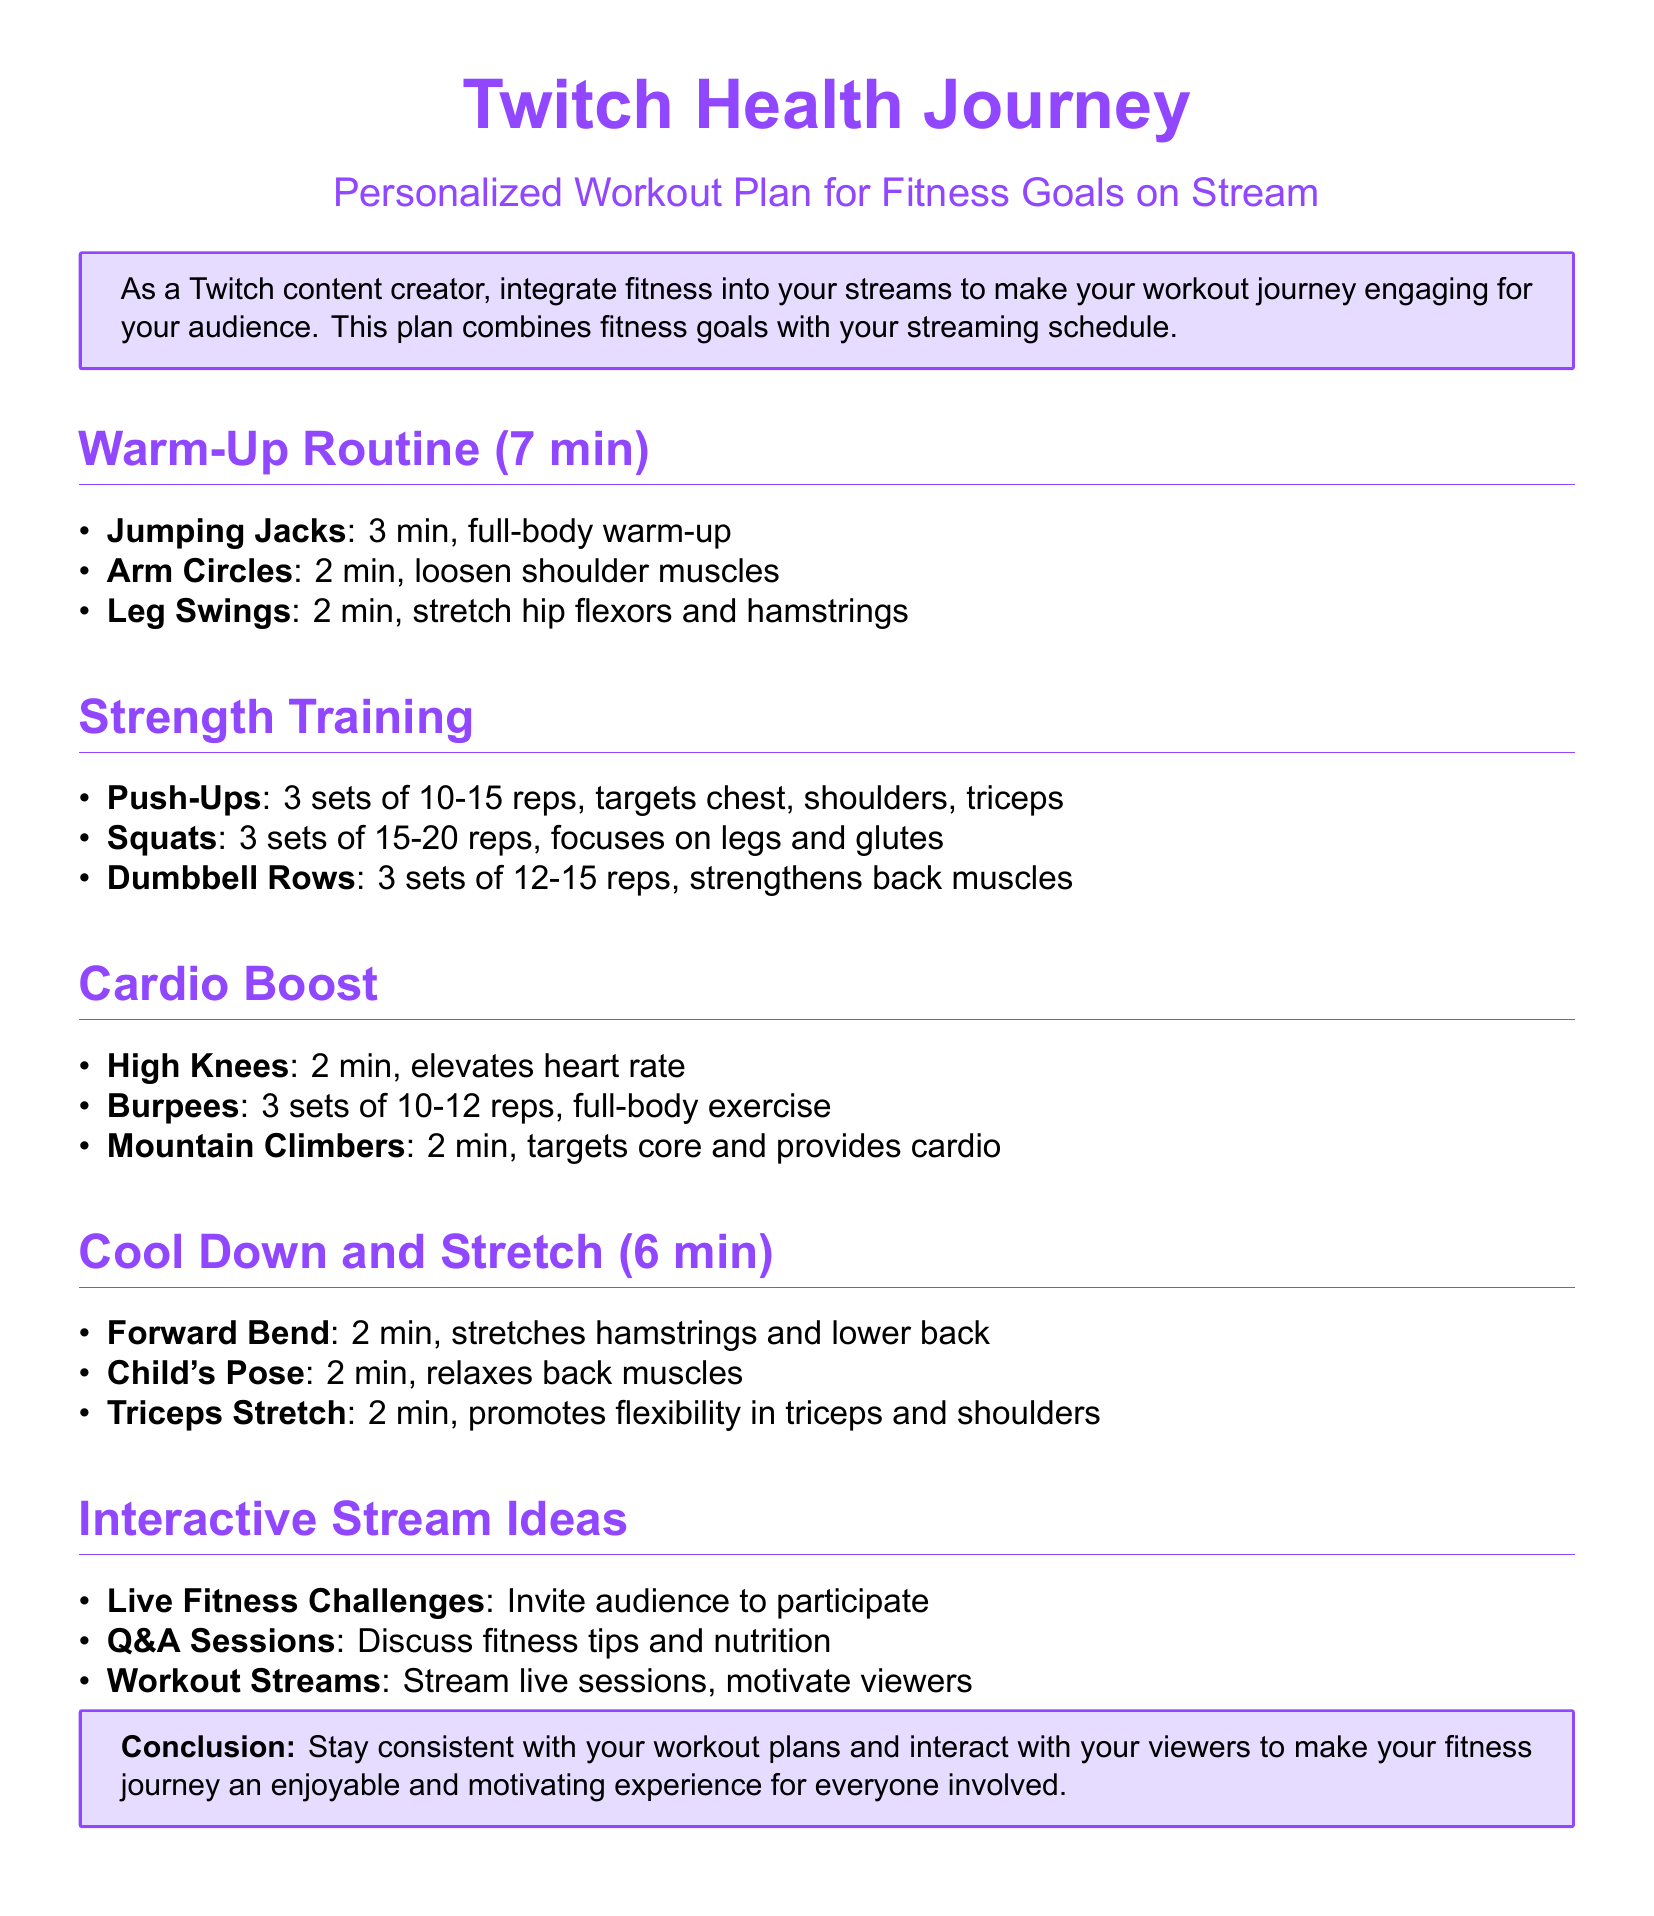What is the duration of the warm-up routine? The warm-up routine lasts for a total of 7 minutes, as indicated in the section title.
Answer: 7 min How many sets of push-ups are included in the strength training? The document specifies that there are 3 sets of push-ups in the strength training section.
Answer: 3 sets What exercise is performed for 2 minutes during the cardio boost? The cardio boost includes several exercises, but high knees is one of them that is performed for 2 minutes.
Answer: High Knees What is one interactive stream idea mentioned in the document? The document lists several ideas; one of them is live fitness challenges.
Answer: Live Fitness Challenges How long does the cool down and stretch section last in total? The cool down and stretch section consists of several exercises that total to 6 minutes as stated in the section title.
Answer: 6 min What type of exercises are included in the strength training section? The strength training section includes strength-building exercises such as push-ups, squats, and dumbbell rows.
Answer: Strength exercises How long should the forward bend stretch be held? The document suggests that the forward bend stretch should be held for 2 minutes.
Answer: 2 min What is the primary focus of squats in the strength training section? The document indicates that squats primarily focus on legs and glutes in the strength training section.
Answer: Legs and glutes 